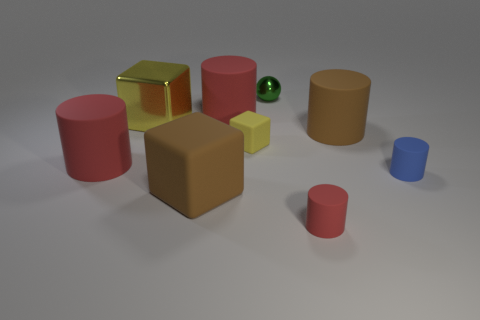How many red cylinders must be subtracted to get 1 red cylinders? 2 Subtract all purple cubes. How many red cylinders are left? 3 Subtract 2 cylinders. How many cylinders are left? 3 Subtract all green cylinders. Subtract all red spheres. How many cylinders are left? 5 Subtract all blocks. How many objects are left? 6 Add 9 small rubber cubes. How many small rubber cubes are left? 10 Add 2 large yellow balls. How many large yellow balls exist? 2 Subtract 0 red spheres. How many objects are left? 9 Subtract all brown matte objects. Subtract all tiny yellow blocks. How many objects are left? 6 